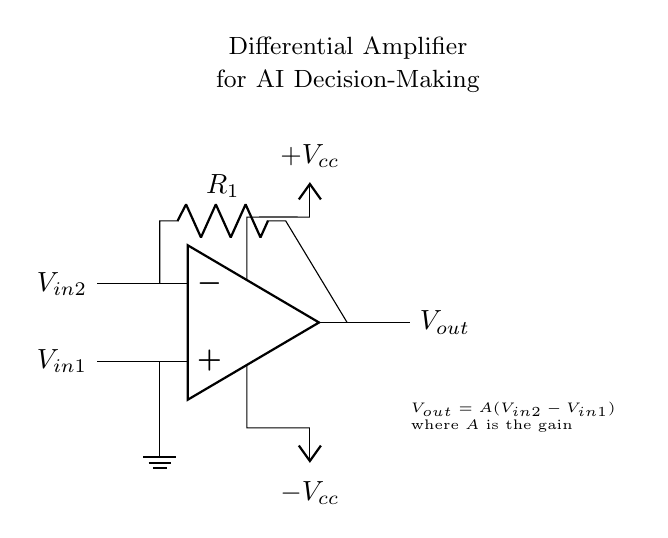What is the type of amplifier shown in the circuit? The circuit is labeled as a "Differential Amplifier," which indicates it is designed to compare two input signals.
Answer: Differential Amplifier What are the two input voltages to the op-amp? The circuit diagram indicates the inputs are labeled as V in 1 and V in 2, which are the two signals being compared by the differential amplifier.
Answer: V in 1 and V in 2 What does the output voltage depend on? The output voltage, labeled as V out, is defined by the equation "V out = A(V in 2 - V in 1)," indicating that it depends on the difference between the two input voltages and the gain A.
Answer: A(V in 2 - V in 1) What component is used to set the gain of the amplifier? The gain of the amplifier is set by the resistor R1, which is connected between the output of the op-amp and one of the input terminals, influencing the amplification factor.
Answer: R1 What is the role of the positive and negative voltage supply in this circuit? The positive and negative supplies, represented as V cc and negative V cc, provide the necessary power for the operation of the op-amp, allowing it to amplify the input signals correctly within its operational range.
Answer: V cc and negative V cc How is the output voltage derived from the two input signals? The output voltage is derived from the equation provided in the diagram, which states that the output voltage equals the gain multiplied by the difference of the two input voltages, indicating a direct relationship with the inputs.
Answer: V out = A(V in 2 - V in 1) 